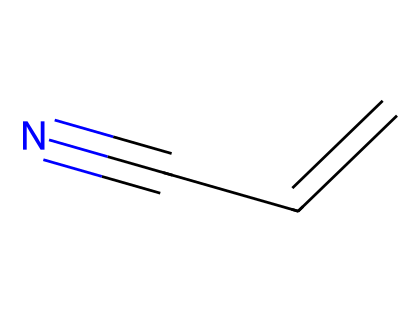What is the name of this chemical? The SMILES representation "C=CC#N" corresponds to acrylonitrile, which is a common nitrile used in manufacturing plastics.
Answer: acrylonitrile How many carbon atoms are present in acrylonitrile? The SMILES shows three carbon atoms (C) in "C=CC#N", so there are three carbon atoms in total.
Answer: three What is the functional group present in acrylonitrile? The presence of the cyano group "C#N" indicates that acrylonitrile has a nitrile functional group.
Answer: nitrile What is the degree of unsaturation in acrylonitrile? The structure has a double bond between the first two carbon atoms (C=C) and a triple bond with the nitrogen (C#N), contributing to the degree of unsaturation. The total degree of unsaturation is 2.
Answer: 2 What is the total number of hydrogen atoms in acrylonitrile? Given the structure C=CC#N, there are three hydrogen atoms attached to the three carbon atoms when considering their bonding, leading to a total of three hydrogen atoms.
Answer: three What type of reaction can acrylonitrile undergo? As a nitrile, acrylonitrile can undergo hydrolysis to form carboxylic acids, which is characteristic of nitrile compounds.
Answer: hydrolysis What is one application of acrylonitrile? Acrylonitrile is commonly used as a precursor in the production of synthetic fibers and plastics, which are important in various industries.
Answer: synthetic fibers 